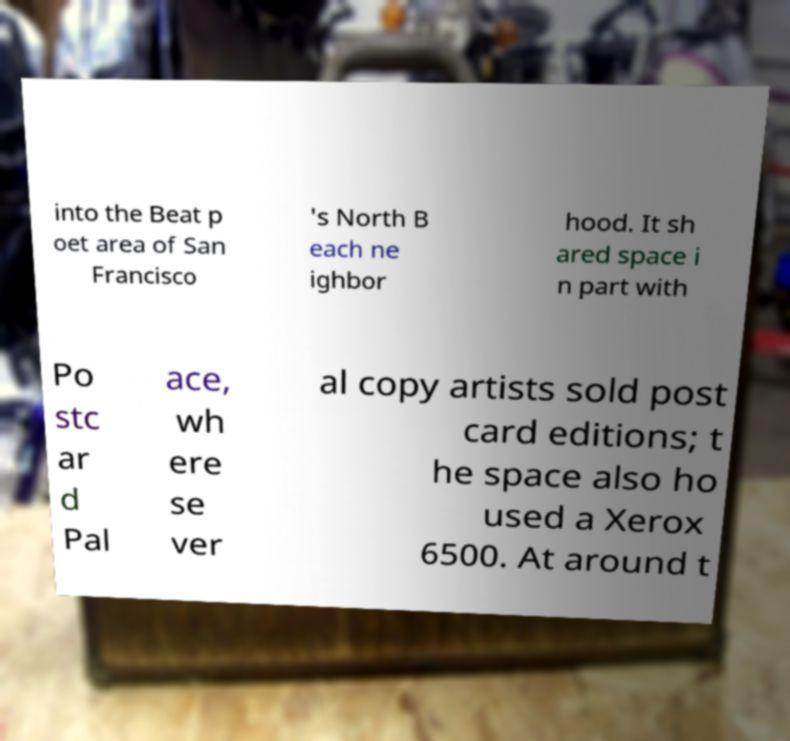Can you accurately transcribe the text from the provided image for me? into the Beat p oet area of San Francisco 's North B each ne ighbor hood. It sh ared space i n part with Po stc ar d Pal ace, wh ere se ver al copy artists sold post card editions; t he space also ho used a Xerox 6500. At around t 